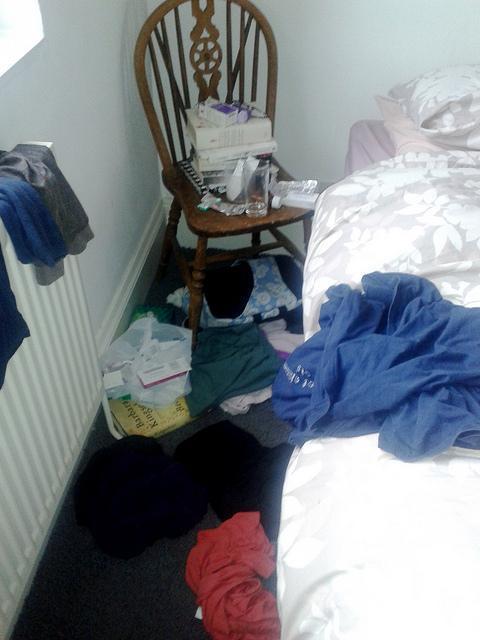How many people in this photo are wearing some form of footwear?
Give a very brief answer. 0. 